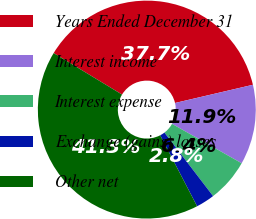<chart> <loc_0><loc_0><loc_500><loc_500><pie_chart><fcel>Years Ended December 31<fcel>Interest income<fcel>Interest expense<fcel>Exchange (gains) losses<fcel>Other net<nl><fcel>37.67%<fcel>11.85%<fcel>6.4%<fcel>2.77%<fcel>41.31%<nl></chart> 